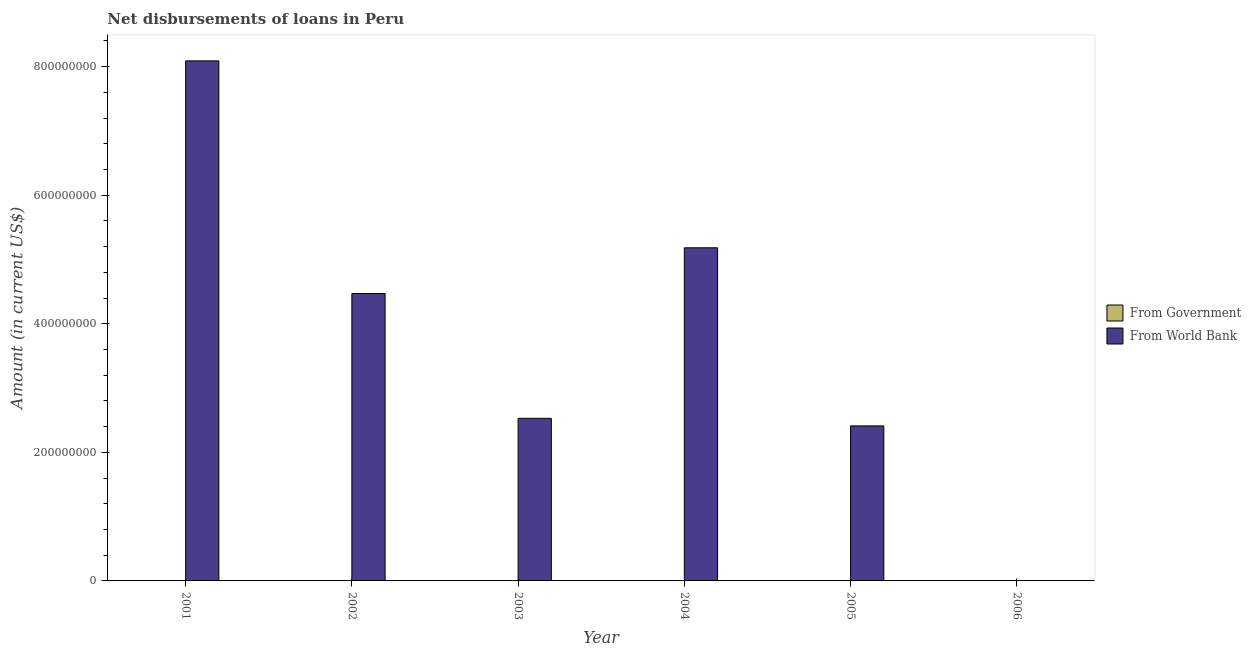Are the number of bars per tick equal to the number of legend labels?
Offer a terse response. No. Are the number of bars on each tick of the X-axis equal?
Your answer should be very brief. No. How many bars are there on the 4th tick from the left?
Make the answer very short. 1. Across all years, what is the maximum net disbursements of loan from world bank?
Make the answer very short. 8.09e+08. In which year was the net disbursements of loan from world bank maximum?
Provide a short and direct response. 2001. What is the difference between the net disbursements of loan from world bank in 2001 and that in 2002?
Offer a terse response. 3.62e+08. What is the difference between the net disbursements of loan from world bank in 2005 and the net disbursements of loan from government in 2001?
Your response must be concise. -5.68e+08. What is the average net disbursements of loan from world bank per year?
Your response must be concise. 3.78e+08. In the year 2004, what is the difference between the net disbursements of loan from world bank and net disbursements of loan from government?
Make the answer very short. 0. In how many years, is the net disbursements of loan from government greater than 480000000 US$?
Offer a terse response. 0. What is the ratio of the net disbursements of loan from world bank in 2001 to that in 2003?
Provide a short and direct response. 3.2. Is the difference between the net disbursements of loan from world bank in 2003 and 2004 greater than the difference between the net disbursements of loan from government in 2003 and 2004?
Provide a short and direct response. No. What is the difference between the highest and the second highest net disbursements of loan from world bank?
Provide a short and direct response. 2.91e+08. What is the difference between the highest and the lowest net disbursements of loan from world bank?
Make the answer very short. 8.09e+08. Is the sum of the net disbursements of loan from world bank in 2002 and 2005 greater than the maximum net disbursements of loan from government across all years?
Your answer should be compact. No. Are all the bars in the graph horizontal?
Make the answer very short. No. Are the values on the major ticks of Y-axis written in scientific E-notation?
Ensure brevity in your answer.  No. Does the graph contain any zero values?
Offer a terse response. Yes. Where does the legend appear in the graph?
Give a very brief answer. Center right. What is the title of the graph?
Your response must be concise. Net disbursements of loans in Peru. What is the label or title of the Y-axis?
Your answer should be very brief. Amount (in current US$). What is the Amount (in current US$) of From Government in 2001?
Ensure brevity in your answer.  0. What is the Amount (in current US$) of From World Bank in 2001?
Offer a terse response. 8.09e+08. What is the Amount (in current US$) of From World Bank in 2002?
Ensure brevity in your answer.  4.47e+08. What is the Amount (in current US$) of From World Bank in 2003?
Provide a succinct answer. 2.53e+08. What is the Amount (in current US$) of From World Bank in 2004?
Your answer should be very brief. 5.18e+08. What is the Amount (in current US$) in From Government in 2005?
Offer a terse response. 0. What is the Amount (in current US$) in From World Bank in 2005?
Give a very brief answer. 2.41e+08. Across all years, what is the maximum Amount (in current US$) in From World Bank?
Make the answer very short. 8.09e+08. Across all years, what is the minimum Amount (in current US$) in From World Bank?
Your response must be concise. 0. What is the total Amount (in current US$) of From World Bank in the graph?
Ensure brevity in your answer.  2.27e+09. What is the difference between the Amount (in current US$) of From World Bank in 2001 and that in 2002?
Provide a short and direct response. 3.62e+08. What is the difference between the Amount (in current US$) of From World Bank in 2001 and that in 2003?
Keep it short and to the point. 5.56e+08. What is the difference between the Amount (in current US$) in From World Bank in 2001 and that in 2004?
Offer a very short reply. 2.91e+08. What is the difference between the Amount (in current US$) in From World Bank in 2001 and that in 2005?
Your answer should be compact. 5.68e+08. What is the difference between the Amount (in current US$) of From World Bank in 2002 and that in 2003?
Keep it short and to the point. 1.94e+08. What is the difference between the Amount (in current US$) of From World Bank in 2002 and that in 2004?
Keep it short and to the point. -7.11e+07. What is the difference between the Amount (in current US$) of From World Bank in 2002 and that in 2005?
Your response must be concise. 2.06e+08. What is the difference between the Amount (in current US$) in From World Bank in 2003 and that in 2004?
Keep it short and to the point. -2.65e+08. What is the difference between the Amount (in current US$) in From World Bank in 2003 and that in 2005?
Your answer should be compact. 1.18e+07. What is the difference between the Amount (in current US$) in From World Bank in 2004 and that in 2005?
Provide a short and direct response. 2.77e+08. What is the average Amount (in current US$) of From Government per year?
Offer a very short reply. 0. What is the average Amount (in current US$) in From World Bank per year?
Offer a very short reply. 3.78e+08. What is the ratio of the Amount (in current US$) of From World Bank in 2001 to that in 2002?
Ensure brevity in your answer.  1.81. What is the ratio of the Amount (in current US$) in From World Bank in 2001 to that in 2003?
Ensure brevity in your answer.  3.2. What is the ratio of the Amount (in current US$) in From World Bank in 2001 to that in 2004?
Offer a very short reply. 1.56. What is the ratio of the Amount (in current US$) of From World Bank in 2001 to that in 2005?
Offer a terse response. 3.35. What is the ratio of the Amount (in current US$) in From World Bank in 2002 to that in 2003?
Give a very brief answer. 1.77. What is the ratio of the Amount (in current US$) of From World Bank in 2002 to that in 2004?
Provide a succinct answer. 0.86. What is the ratio of the Amount (in current US$) in From World Bank in 2002 to that in 2005?
Make the answer very short. 1.85. What is the ratio of the Amount (in current US$) in From World Bank in 2003 to that in 2004?
Offer a very short reply. 0.49. What is the ratio of the Amount (in current US$) of From World Bank in 2003 to that in 2005?
Offer a very short reply. 1.05. What is the ratio of the Amount (in current US$) in From World Bank in 2004 to that in 2005?
Give a very brief answer. 2.15. What is the difference between the highest and the second highest Amount (in current US$) of From World Bank?
Your answer should be compact. 2.91e+08. What is the difference between the highest and the lowest Amount (in current US$) of From World Bank?
Give a very brief answer. 8.09e+08. 